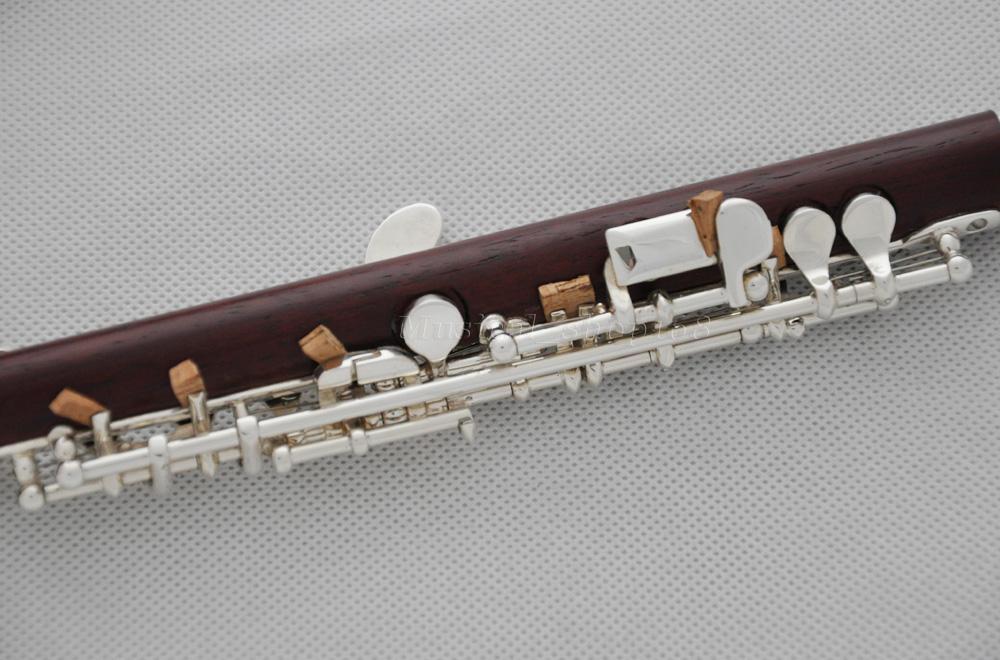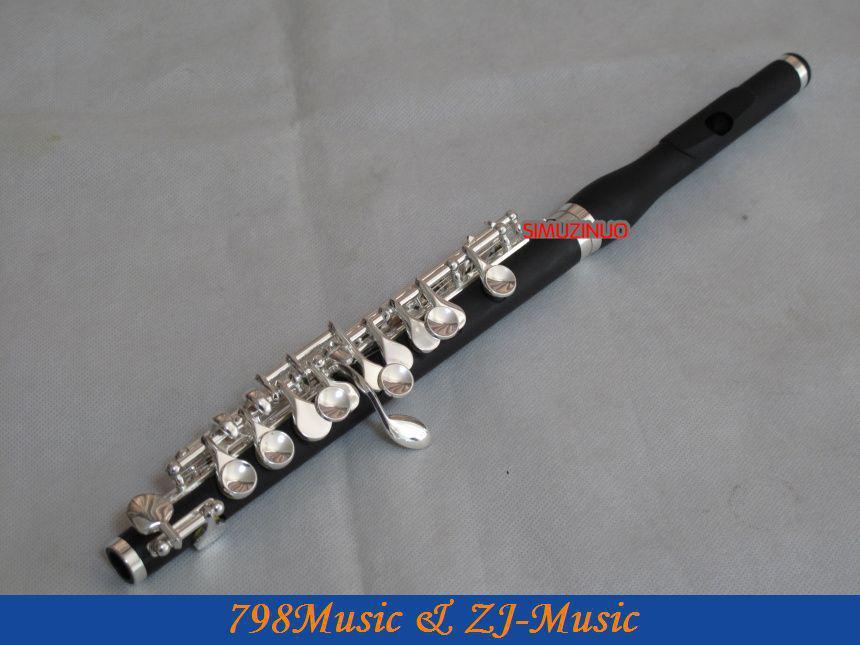The first image is the image on the left, the second image is the image on the right. Given the left and right images, does the statement "The left image contains only a diagonally displayed flute with metal buttons, and the right image includes only a diagonally displayed flute without metal buttons." hold true? Answer yes or no. No. The first image is the image on the left, the second image is the image on the right. For the images displayed, is the sentence "One of the images shows an instrument with buttons that are pressed to change notes while the other just has finger holes that get covered to changed notes." factually correct? Answer yes or no. No. 